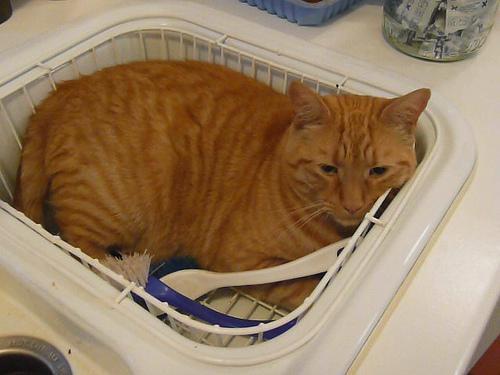How many brushes are in the sink?
Give a very brief answer. 2. How many cats are pictured?
Give a very brief answer. 1. How many cats are there?
Give a very brief answer. 1. How many brushes with the cat?
Give a very brief answer. 2. How many eyes does the cat have?
Give a very brief answer. 2. How many ears does the cat have?
Give a very brief answer. 2. How many brown cats are in the picture?
Give a very brief answer. 1. 